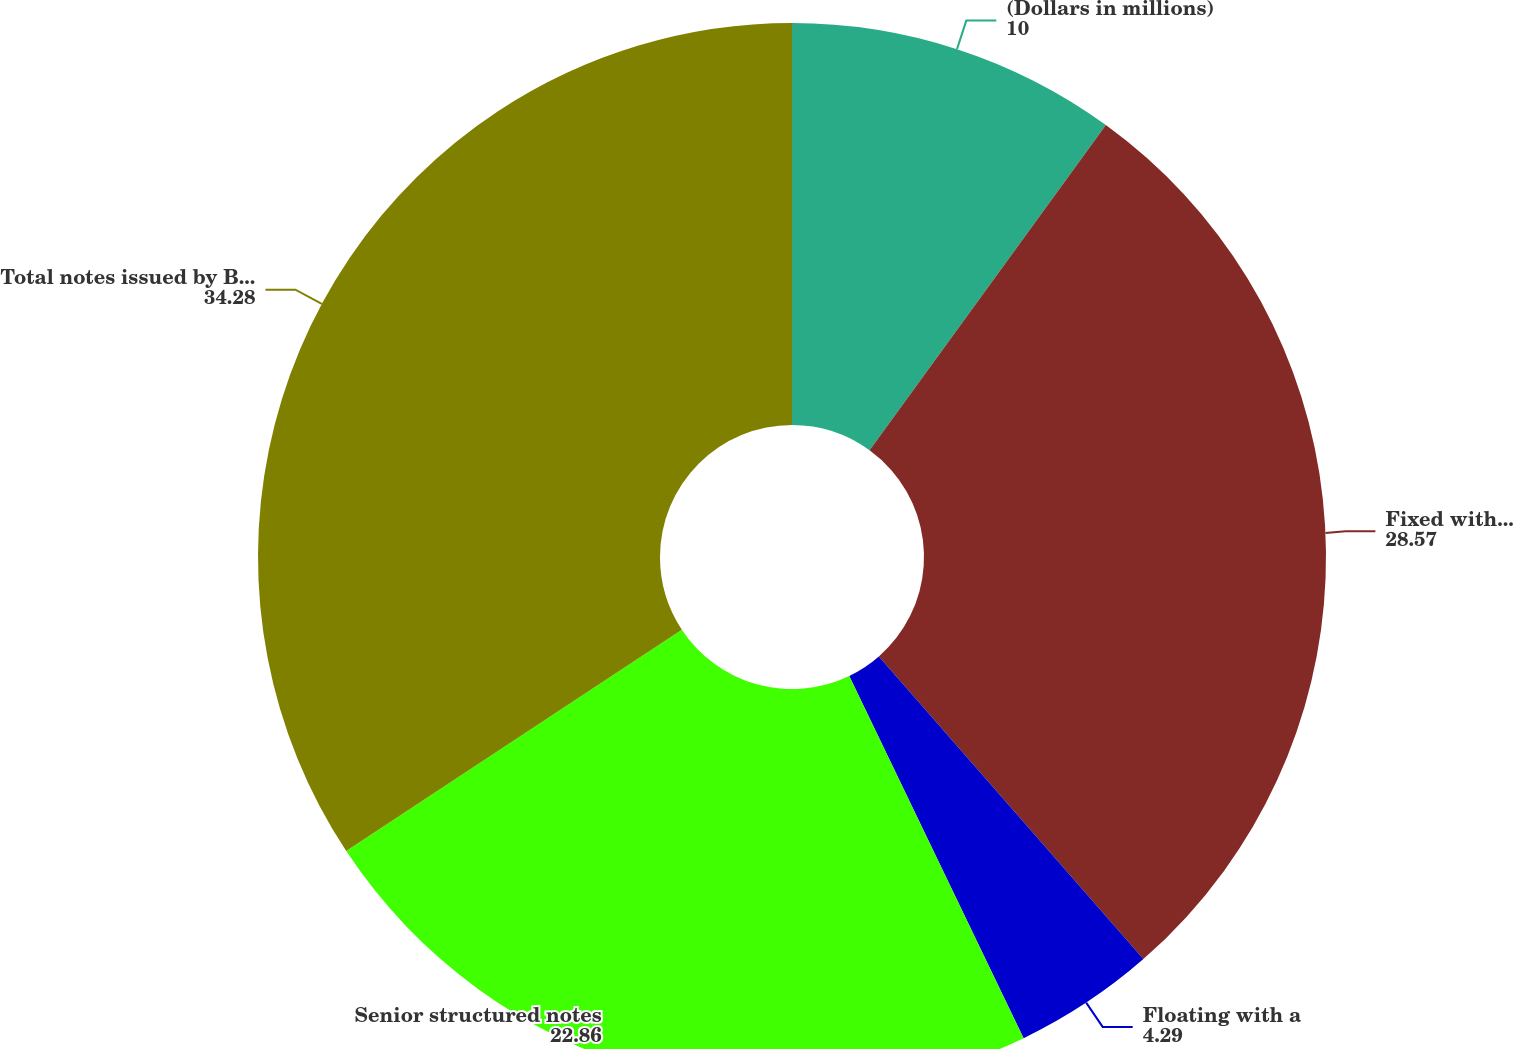<chart> <loc_0><loc_0><loc_500><loc_500><pie_chart><fcel>(Dollars in millions)<fcel>Fixed with a weighted-average<fcel>Floating with a<fcel>Senior structured notes<fcel>Total notes issued by Bank of<nl><fcel>10.0%<fcel>28.57%<fcel>4.29%<fcel>22.86%<fcel>34.28%<nl></chart> 